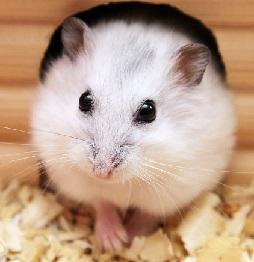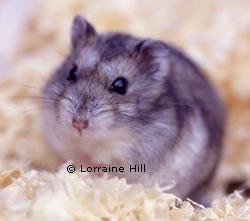The first image is the image on the left, the second image is the image on the right. For the images shown, is this caption "An image shows one rodent pet lying with its belly flat on a light-colored wood surface." true? Answer yes or no. No. The first image is the image on the left, the second image is the image on the right. Evaluate the accuracy of this statement regarding the images: "A rodent is lying across a flat glossy surface in one of the images.". Is it true? Answer yes or no. No. 